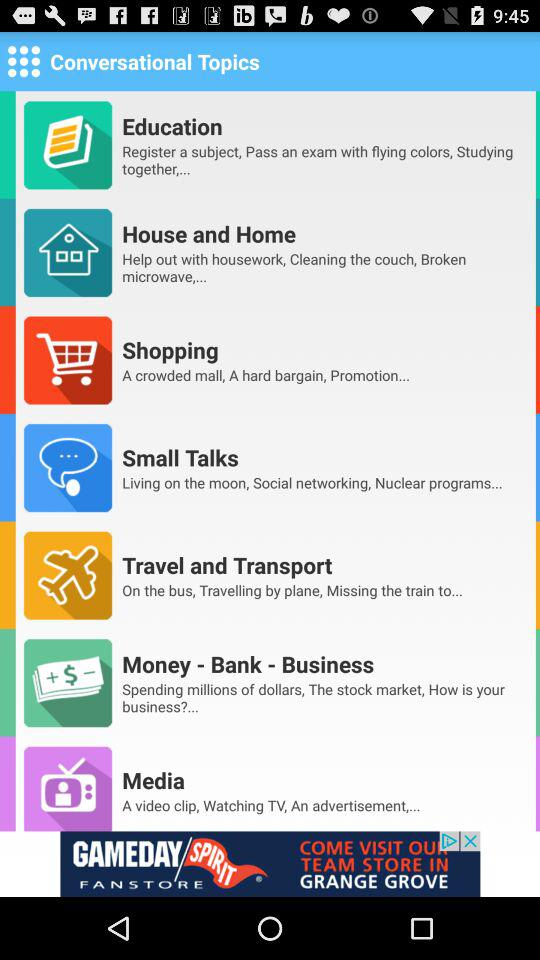What are the conversational topics? The conversational topics are "Education", "House and Home", "Shopping", "Small Talks", "Travel and Transport", "Money - Bank - Business" and "Media". 